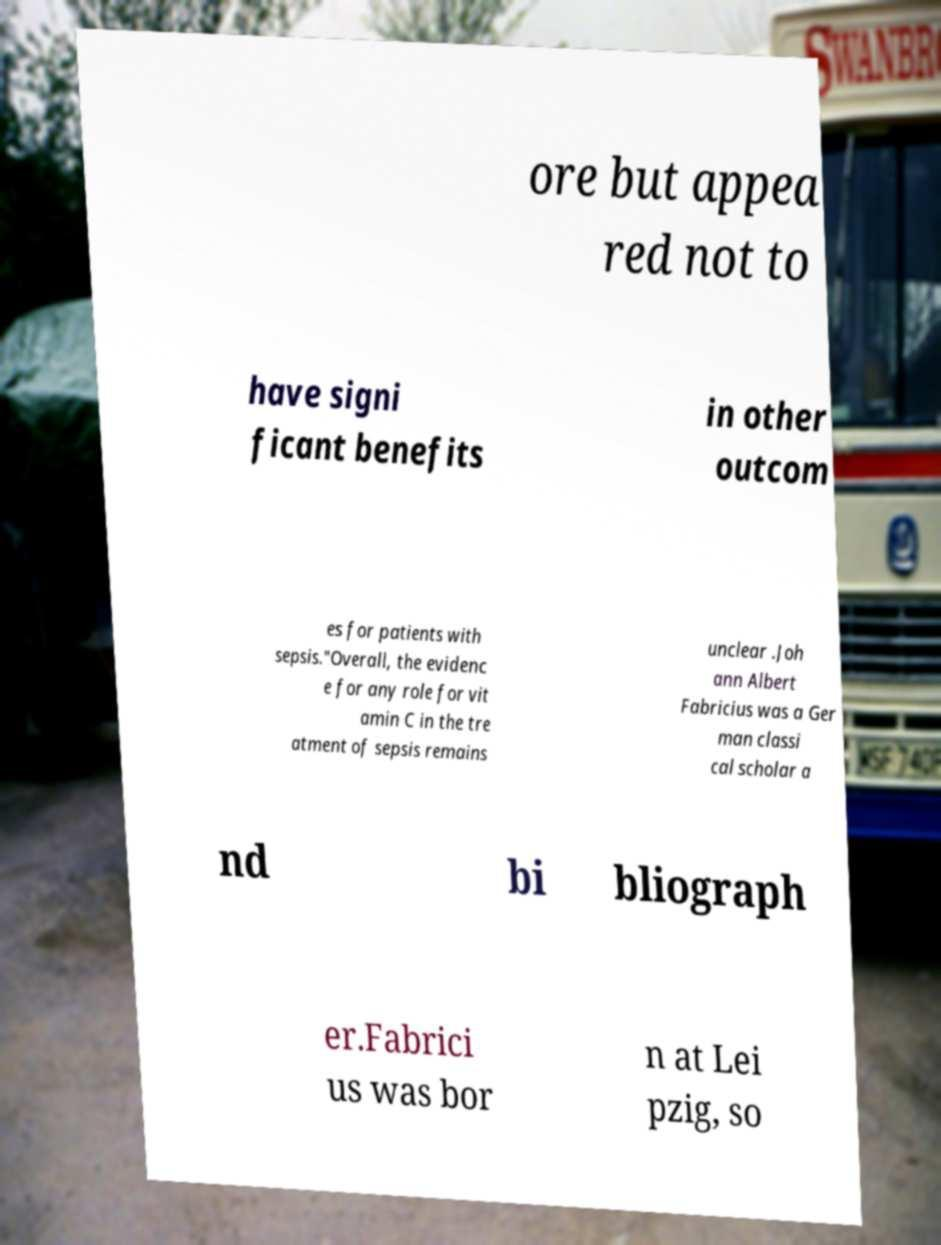Could you assist in decoding the text presented in this image and type it out clearly? ore but appea red not to have signi ficant benefits in other outcom es for patients with sepsis."Overall, the evidenc e for any role for vit amin C in the tre atment of sepsis remains unclear .Joh ann Albert Fabricius was a Ger man classi cal scholar a nd bi bliograph er.Fabrici us was bor n at Lei pzig, so 